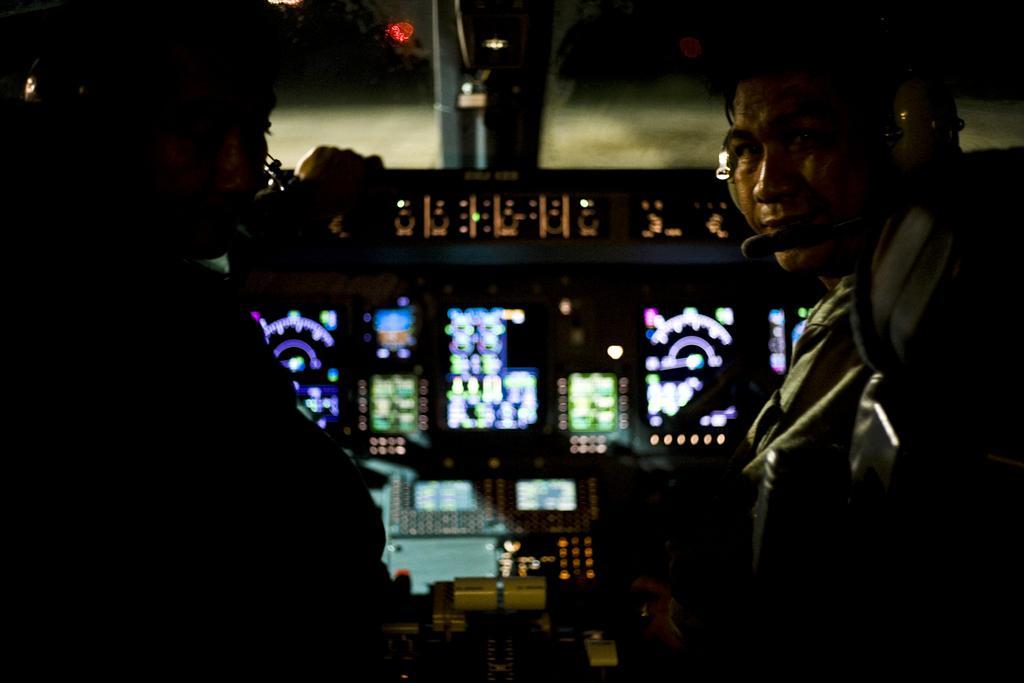In one or two sentences, can you explain what this image depicts? In this image we can see the people. We can also see some equipment, wall and also the light. 